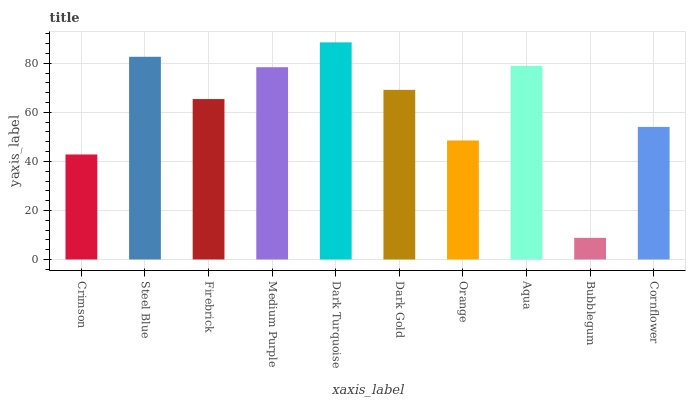Is Bubblegum the minimum?
Answer yes or no. Yes. Is Dark Turquoise the maximum?
Answer yes or no. Yes. Is Steel Blue the minimum?
Answer yes or no. No. Is Steel Blue the maximum?
Answer yes or no. No. Is Steel Blue greater than Crimson?
Answer yes or no. Yes. Is Crimson less than Steel Blue?
Answer yes or no. Yes. Is Crimson greater than Steel Blue?
Answer yes or no. No. Is Steel Blue less than Crimson?
Answer yes or no. No. Is Dark Gold the high median?
Answer yes or no. Yes. Is Firebrick the low median?
Answer yes or no. Yes. Is Aqua the high median?
Answer yes or no. No. Is Dark Gold the low median?
Answer yes or no. No. 